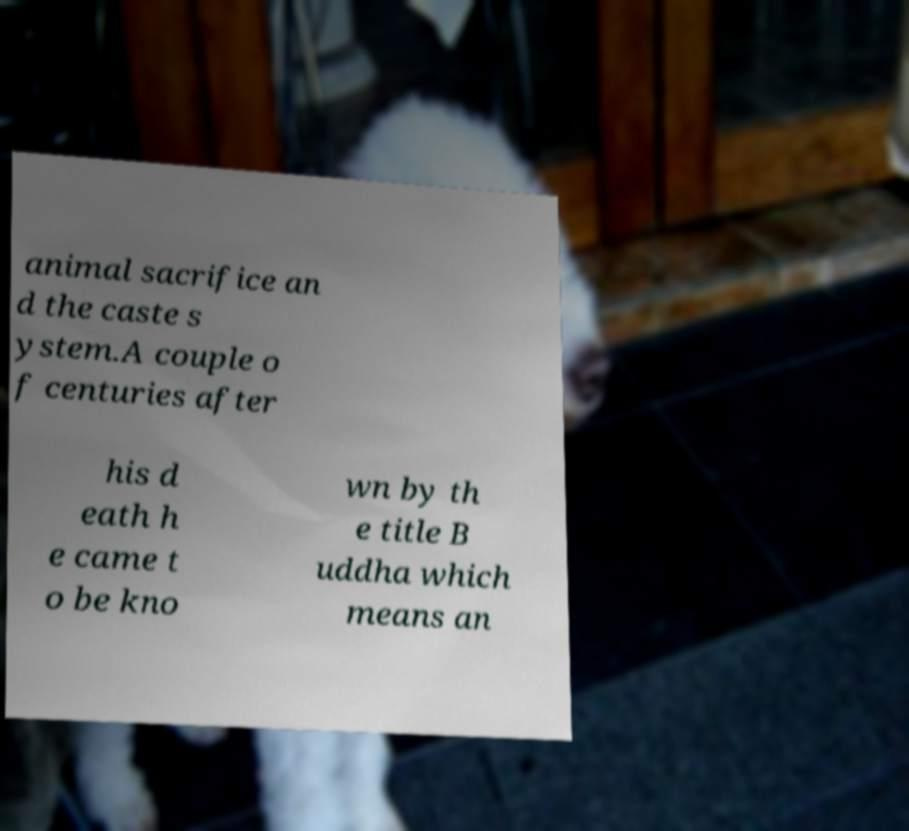Could you assist in decoding the text presented in this image and type it out clearly? animal sacrifice an d the caste s ystem.A couple o f centuries after his d eath h e came t o be kno wn by th e title B uddha which means an 